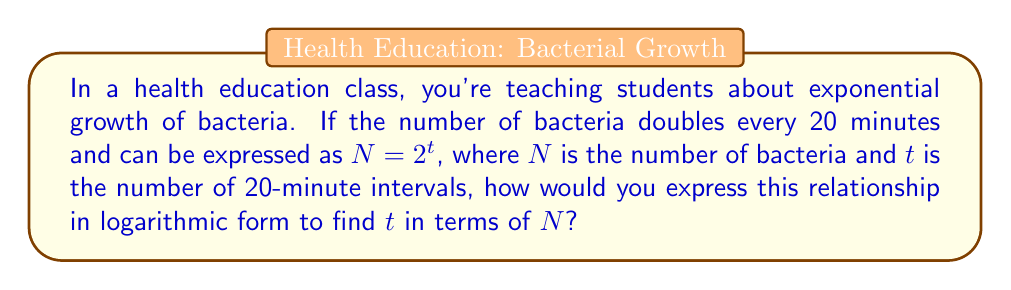Can you answer this question? To convert this exponential equation into logarithmic form, we can follow these steps:

1) Start with the exponential equation:
   $N = 2^t$

2) To isolate $t$, we need to apply the logarithm (base 2) to both sides:
   $\log_2(N) = \log_2(2^t)$

3) Using the logarithm property $\log_a(a^x) = x$, we can simplify the right side:
   $\log_2(N) = t$

4) To express $t$ in terms of $N$, we simply need to rearrange the equation:
   $t = \log_2(N)$

This logarithmic form allows us to find the number of 20-minute intervals ($t$) when we know the number of bacteria ($N$).
Answer: $t = \log_2(N)$ 